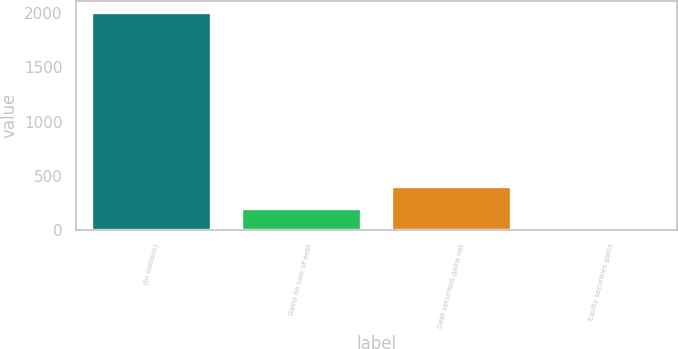Convert chart to OTSL. <chart><loc_0><loc_0><loc_500><loc_500><bar_chart><fcel>(in millions)<fcel>Gains on sale of debt<fcel>Debt securities gains net<fcel>Equity securities gains<nl><fcel>2017<fcel>202.6<fcel>404.2<fcel>1<nl></chart> 